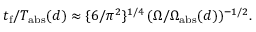Convert formula to latex. <formula><loc_0><loc_0><loc_500><loc_500>t _ { f } / T _ { a b s } ( d ) \approx \{ 6 / \pi ^ { 2 } \} ^ { 1 / 4 } \, ( \Omega / \Omega _ { a b s } ( d ) ) ^ { - 1 / 2 } .</formula> 